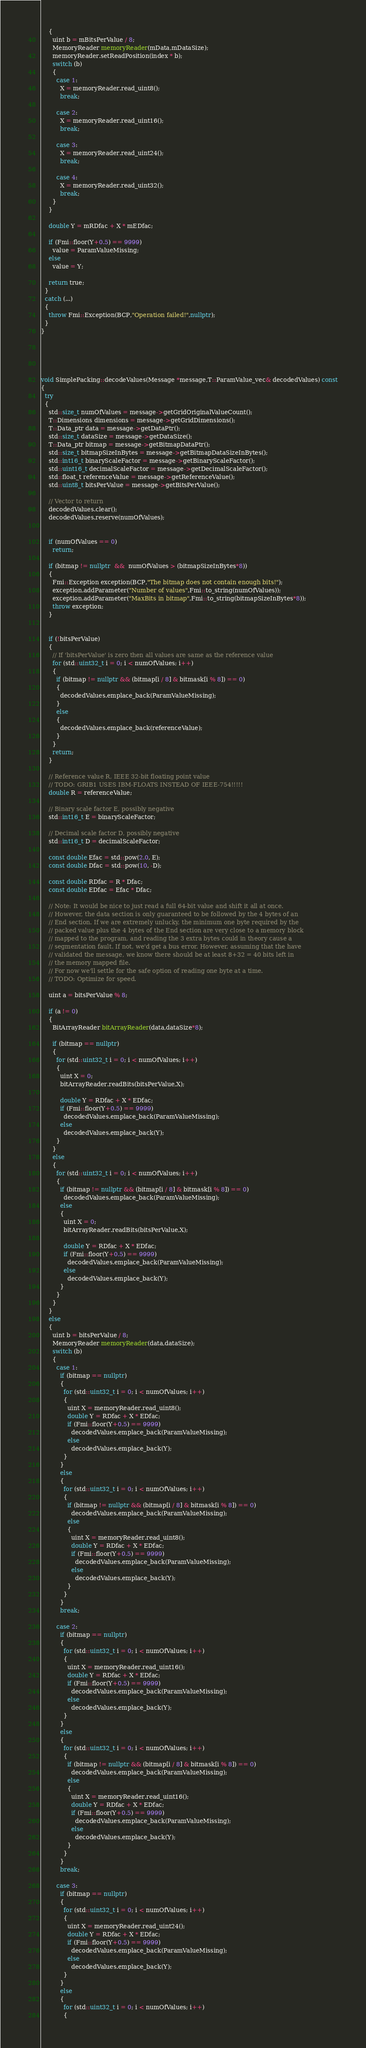Convert code to text. <code><loc_0><loc_0><loc_500><loc_500><_C++_>    {
      uint b = mBitsPerValue / 8;
      MemoryReader memoryReader(mData,mDataSize);
      memoryReader.setReadPosition(index * b);
      switch (b)
      {
        case 1:
          X = memoryReader.read_uint8();
          break;

        case 2:
          X = memoryReader.read_uint16();
          break;

        case 3:
          X = memoryReader.read_uint24();
          break;

        case 4:
          X = memoryReader.read_uint32();
          break;
      }
    }

    double Y = mRDfac + X * mEDfac;

    if (Fmi::floor(Y+0.5) == 9999)
      value = ParamValueMissing;
    else
      value = Y;

    return true;
  }
  catch (...)
  {
    throw Fmi::Exception(BCP,"Operation failed!",nullptr);
  }
}





void SimplePacking::decodeValues(Message *message,T::ParamValue_vec& decodedValues) const
{
  try
  {
    std::size_t numOfValues = message->getGridOriginalValueCount();
    T::Dimensions dimensions = message->getGridDimensions();
    T::Data_ptr data = message->getDataPtr();
    std::size_t dataSize = message->getDataSize();
    T::Data_ptr bitmap = message->getBitmapDataPtr();
    std::size_t bitmapSizeInBytes = message->getBitmapDataSizeInBytes();
    std::int16_t binaryScaleFactor = message->getBinaryScaleFactor();
    std::uint16_t decimalScaleFactor = message->getDecimalScaleFactor();
    std::float_t referenceValue = message->getReferenceValue();
    std::uint8_t bitsPerValue = message->getBitsPerValue();

    // Vector to return
    decodedValues.clear();
    decodedValues.reserve(numOfValues);


    if (numOfValues == 0)
      return;

    if (bitmap != nullptr  &&  numOfValues > (bitmapSizeInBytes*8))
    {
      Fmi::Exception exception(BCP,"The bitmap does not contain enough bits!");
      exception.addParameter("Number of values",Fmi::to_string(numOfValues));
      exception.addParameter("MaxBits in bitmap",Fmi::to_string(bitmapSizeInBytes*8));
      throw exception;
    }


    if (!bitsPerValue)
    {
      // If 'bitsPerValue' is zero then all values are same as the reference value
      for (std::uint32_t i = 0; i < numOfValues; i++)
      {
        if (bitmap != nullptr && (bitmap[i / 8] & bitmask[i % 8]) == 0)
        {
          decodedValues.emplace_back(ParamValueMissing);
        }
        else
        {
          decodedValues.emplace_back(referenceValue);
        }
      }
      return;
    }

    // Reference value R, IEEE 32-bit floating point value
    // TODO: GRIB1 USES IBM-FLOATS INSTEAD OF IEEE-754!!!!!
    double R = referenceValue;

    // Binary scale factor E, possibly negative
    std::int16_t E = binaryScaleFactor;

    // Decimal scale factor D, possibly negative
    std::int16_t D = decimalScaleFactor;

    const double Efac = std::pow(2.0, E);
    const double Dfac = std::pow(10, -D);

    const double RDfac = R * Dfac;
    const double EDfac = Efac * Dfac;

    // Note: It would be nice to just read a full 64-bit value and shift it all at once.
    // However, the data section is only guaranteed to be followed by the 4 bytes of an
    // End section. If we are extremely unlucky, the minimum one byte required by the
    // packed value plus the 4 bytes of the End section are very close to a memory block
    // mapped to the program, and reading the 3 extra bytes could in theory cause a
    // segmentation fault. If not, we'd get a bus error. However, assuming that the have
    // validated the message, we know there should be at least 8+32 = 40 bits left in
    // the memory mapped file.
    // For now we'll settle for the safe option of reading one byte at a time.
    // TODO: Optimize for speed.

    uint a = bitsPerValue % 8;

    if (a != 0)
    {
      BitArrayReader bitArrayReader(data,dataSize*8);

      if (bitmap == nullptr)
      {
        for (std::uint32_t i = 0; i < numOfValues; i++)
        {
          uint X = 0;
          bitArrayReader.readBits(bitsPerValue,X);

          double Y = RDfac + X * EDfac;
          if (Fmi::floor(Y+0.5) == 9999)
            decodedValues.emplace_back(ParamValueMissing);
          else
            decodedValues.emplace_back(Y);
        }
      }
      else
      {
        for (std::uint32_t i = 0; i < numOfValues; i++)
        {
          if (bitmap != nullptr && (bitmap[i / 8] & bitmask[i % 8]) == 0)
            decodedValues.emplace_back(ParamValueMissing);
          else
          {
            uint X = 0;
            bitArrayReader.readBits(bitsPerValue,X);

            double Y = RDfac + X * EDfac;
            if (Fmi::floor(Y+0.5) == 9999)
              decodedValues.emplace_back(ParamValueMissing);
            else
              decodedValues.emplace_back(Y);
          }
        }
      }
    }
    else
    {
      uint b = bitsPerValue / 8;
      MemoryReader memoryReader(data,dataSize);
      switch (b)
      {
        case 1:
          if (bitmap == nullptr)
          {
            for (std::uint32_t i = 0; i < numOfValues; i++)
            {
              uint X = memoryReader.read_uint8();
              double Y = RDfac + X * EDfac;
              if (Fmi::floor(Y+0.5) == 9999)
                decodedValues.emplace_back(ParamValueMissing);
              else
                decodedValues.emplace_back(Y);
            }
          }
          else
          {
            for (std::uint32_t i = 0; i < numOfValues; i++)
            {
              if (bitmap != nullptr && (bitmap[i / 8] & bitmask[i % 8]) == 0)
                decodedValues.emplace_back(ParamValueMissing);
              else
              {
                uint X = memoryReader.read_uint8();
                double Y = RDfac + X * EDfac;
                if (Fmi::floor(Y+0.5) == 9999)
                  decodedValues.emplace_back(ParamValueMissing);
                else
                  decodedValues.emplace_back(Y);
              }
            }
          }
          break;

        case 2:
          if (bitmap == nullptr)
          {
            for (std::uint32_t i = 0; i < numOfValues; i++)
            {
              uint X = memoryReader.read_uint16();
              double Y = RDfac + X * EDfac;
              if (Fmi::floor(Y+0.5) == 9999)
                decodedValues.emplace_back(ParamValueMissing);
              else
                decodedValues.emplace_back(Y);
            }
          }
          else
          {
            for (std::uint32_t i = 0; i < numOfValues; i++)
            {
              if (bitmap != nullptr && (bitmap[i / 8] & bitmask[i % 8]) == 0)
                decodedValues.emplace_back(ParamValueMissing);
              else
              {
                uint X = memoryReader.read_uint16();
                double Y = RDfac + X * EDfac;
                if (Fmi::floor(Y+0.5) == 9999)
                  decodedValues.emplace_back(ParamValueMissing);
                else
                  decodedValues.emplace_back(Y);
              }
            }
          }
          break;

        case 3:
          if (bitmap == nullptr)
          {
            for (std::uint32_t i = 0; i < numOfValues; i++)
            {
              uint X = memoryReader.read_uint24();
              double Y = RDfac + X * EDfac;
              if (Fmi::floor(Y+0.5) == 9999)
                decodedValues.emplace_back(ParamValueMissing);
              else
                decodedValues.emplace_back(Y);
            }
          }
          else
          {
            for (std::uint32_t i = 0; i < numOfValues; i++)
            {</code> 